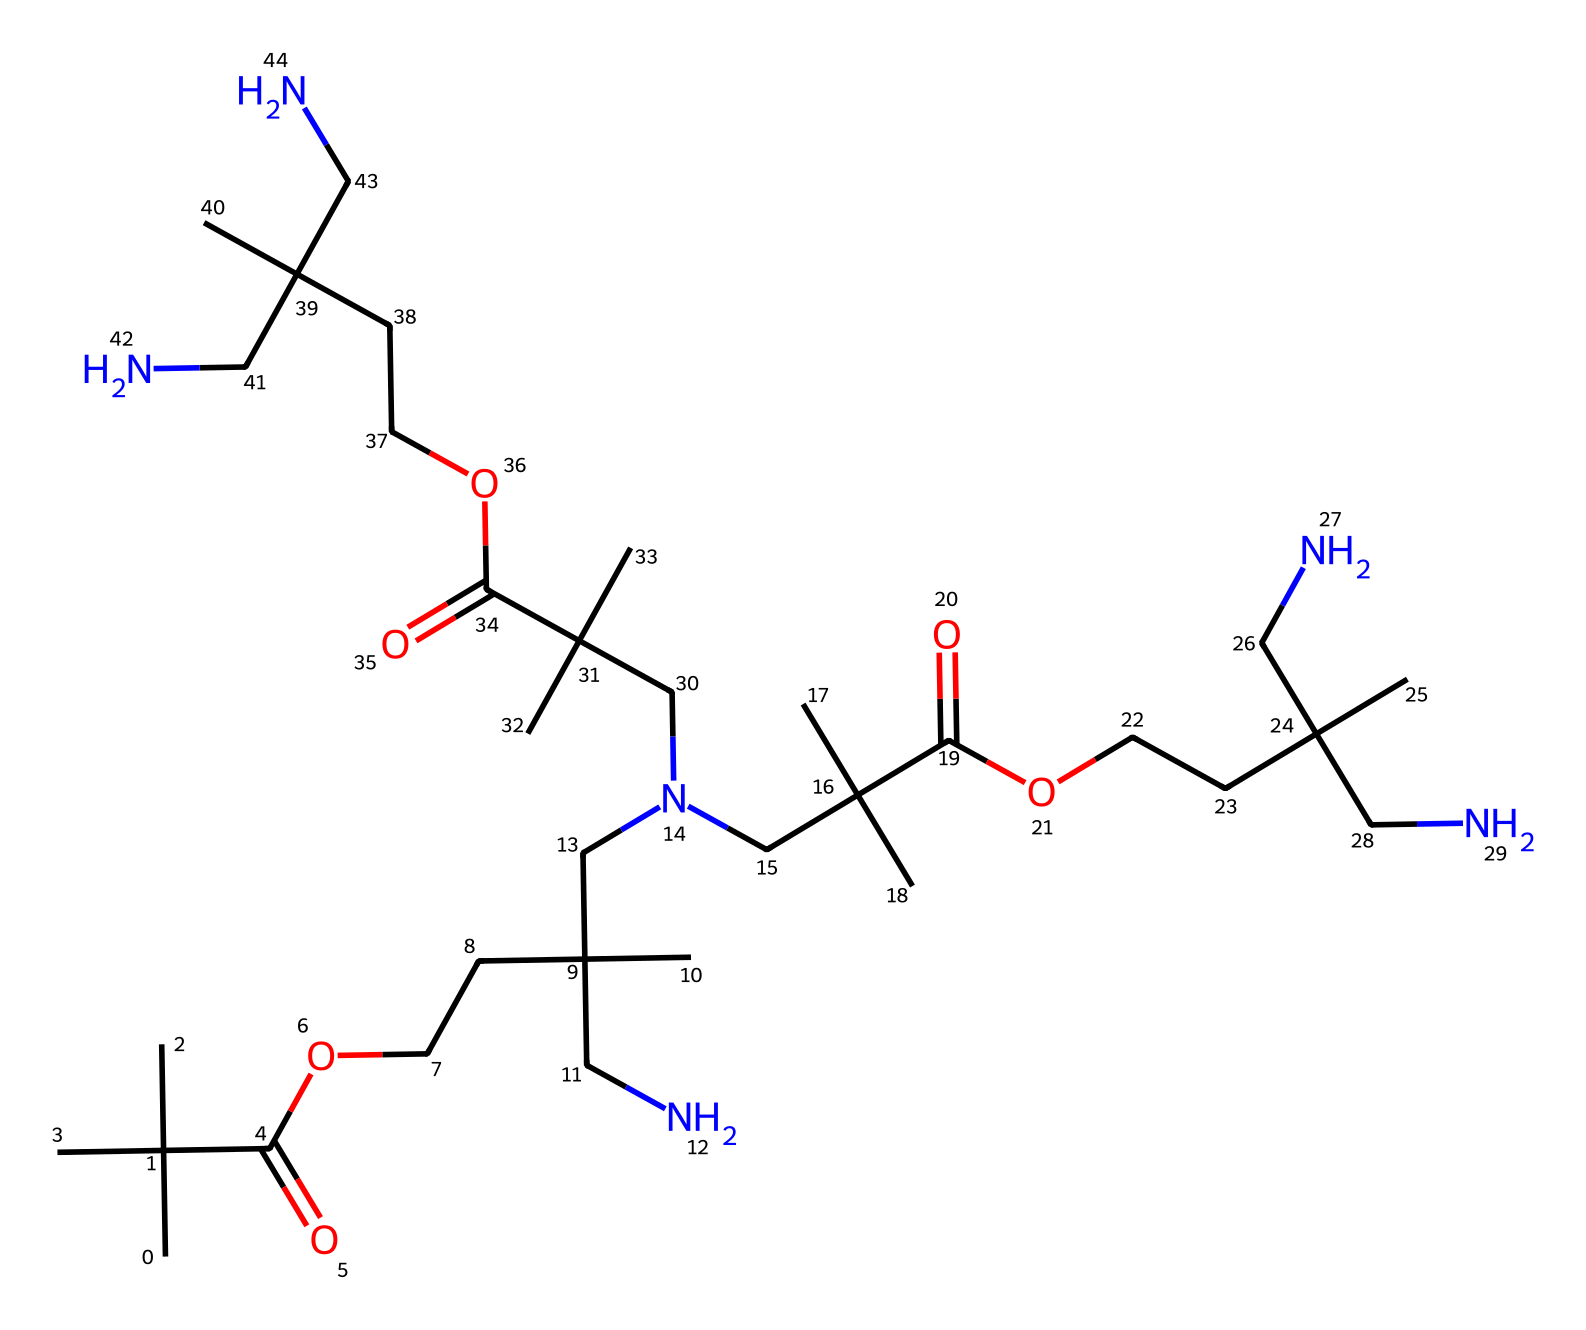What is the chemical class of this structure? The chemical structure features ester and amine functional groups, common in polymers designed for adaptive applications. These functionalities indicate it belongs to the class of polyamides or polyurethanes due to the presence of backbone amines and ester linkages.
Answer: polyamide How many carbon atoms are present in the structure? By analyzing the SMILES representation, each "C" counts for a carbon atom. There are multiple branched groups, and by counting each carbon atom individually from the SMILES, we discover there are 27 carbon atoms.
Answer: 27 What is the functional group associated with flexibility in the polymer? The polymer has ester groups indicated by "C(=O)O" in the structure, which generally confer flexibility to the material. The presence of ester linkages contributes to distinguished material properties suited for adaptive clothing.
Answer: ester What is the significance of the nitrogen atoms in adaptive clothing polymers? The nitrogen atoms present in this structure signify the amine functional groups, which impart elasticity and durability to the polymer. This is particularly useful in adaptive clothing, allowing for comfort and movement for individuals with disabilities.
Answer: elasticity How many functional groups are present in the molecule? Identifying the repeating units within the polymer based on the SMILES and locational details shows that there are three ester groups and multiple amine groups. Each segment contains both, totaling to 3 esters and several amines which increase the adaptability.
Answer: six 